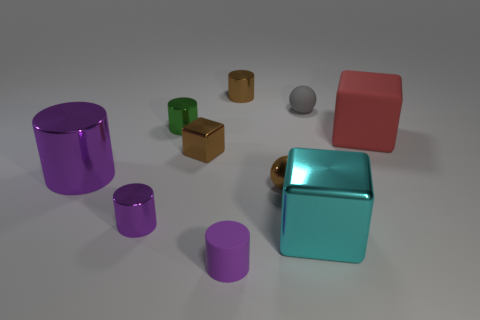Is the material of the sphere that is behind the big purple metallic object the same as the tiny brown thing behind the red block?
Your answer should be compact. No. There is a red matte block behind the small brown cube; what is its size?
Offer a terse response. Large. There is a large purple thing that is the same shape as the small green thing; what is it made of?
Make the answer very short. Metal. Is there any other thing that has the same size as the matte cylinder?
Your answer should be compact. Yes. There is a thing that is to the right of the gray rubber object; what shape is it?
Keep it short and to the point. Cube. What number of other gray rubber things have the same shape as the gray rubber object?
Ensure brevity in your answer.  0. Is the number of tiny brown shiny spheres on the left side of the rubber cylinder the same as the number of tiny purple rubber things that are behind the brown block?
Offer a terse response. Yes. Are there any small brown cylinders that have the same material as the green object?
Your response must be concise. Yes. Does the cyan block have the same material as the gray sphere?
Offer a terse response. No. What number of green things are either small matte cylinders or matte cubes?
Your response must be concise. 0. 